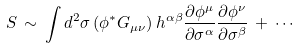<formula> <loc_0><loc_0><loc_500><loc_500>S \, \sim \, \int d ^ { 2 } \sigma \left ( \phi ^ { * } G _ { \mu \nu } \right ) h ^ { \alpha \beta } \frac { \partial \phi ^ { \mu } } { \partial \sigma ^ { \alpha } } \frac { \partial \phi ^ { \nu } } { \partial \sigma ^ { \beta } } \, + \, \cdots</formula> 